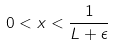<formula> <loc_0><loc_0><loc_500><loc_500>0 < x < \frac { 1 } { L + \epsilon }</formula> 